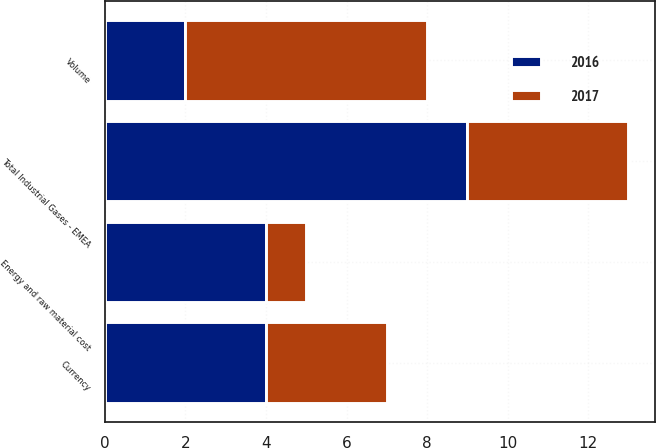Convert chart. <chart><loc_0><loc_0><loc_500><loc_500><stacked_bar_chart><ecel><fcel>Volume<fcel>Energy and raw material cost<fcel>Currency<fcel>Total Industrial Gases - EMEA<nl><fcel>2017<fcel>6<fcel>1<fcel>3<fcel>4<nl><fcel>2016<fcel>2<fcel>4<fcel>4<fcel>9<nl></chart> 